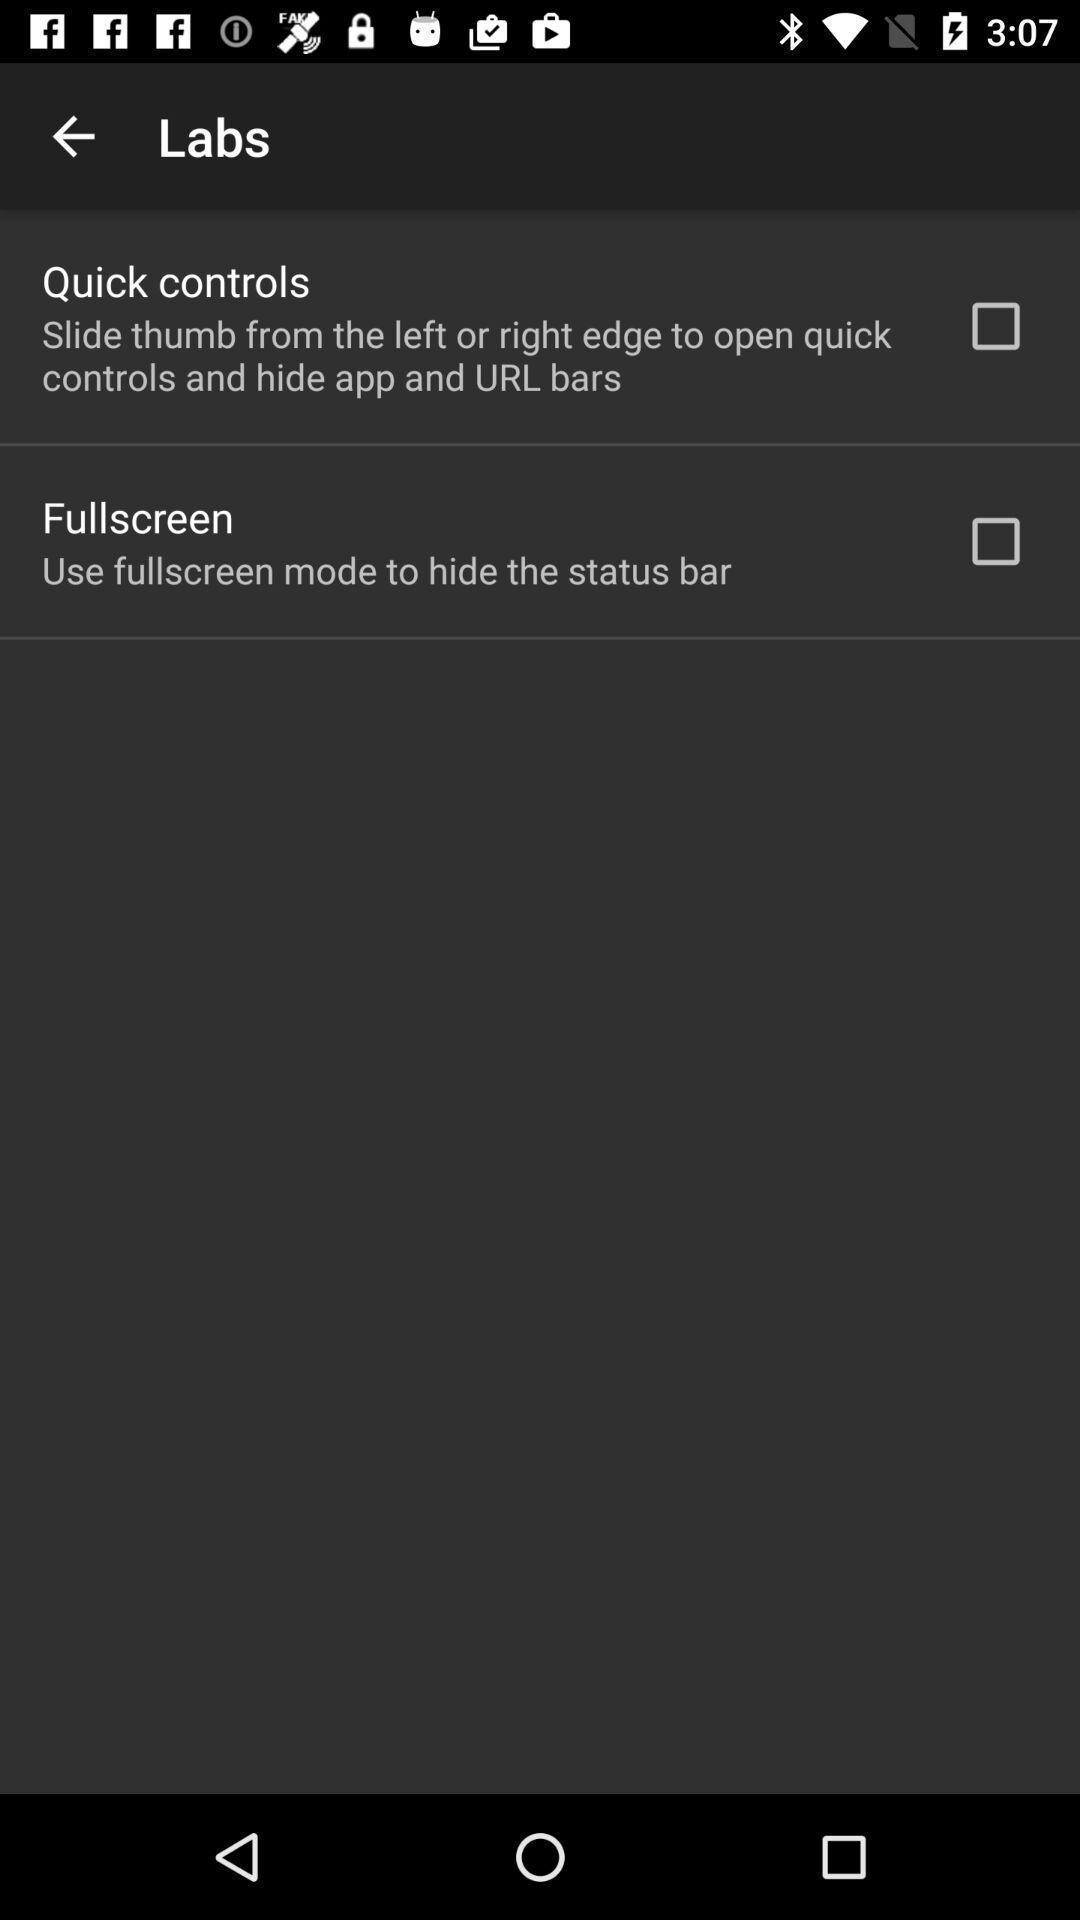Give me a narrative description of this picture. Screen showing quick controls and fullscreen options. 